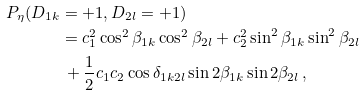Convert formula to latex. <formula><loc_0><loc_0><loc_500><loc_500>P _ { \eta } ( D _ { 1 k } & = + 1 , D _ { 2 l } = + 1 ) \\ & = c _ { 1 } ^ { 2 } \cos ^ { 2 } \beta _ { 1 k } \cos ^ { 2 } \beta _ { 2 l } + c _ { 2 } ^ { 2 } \sin ^ { 2 } \beta _ { 1 k } \sin ^ { 2 } \beta _ { 2 l } \\ & \, + \frac { 1 } { 2 } c _ { 1 } c _ { 2 } \cos \delta _ { 1 k 2 l } \sin 2 \beta _ { 1 k } \sin 2 \beta _ { 2 l } \, ,</formula> 